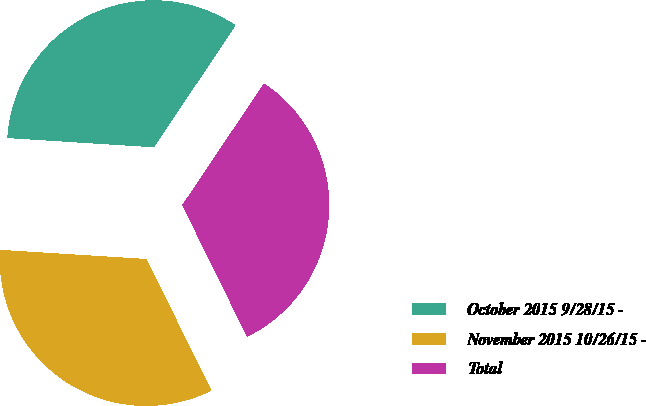Convert chart. <chart><loc_0><loc_0><loc_500><loc_500><pie_chart><fcel>October 2015 9/28/15 -<fcel>November 2015 10/26/15 -<fcel>Total<nl><fcel>33.42%<fcel>33.28%<fcel>33.3%<nl></chart> 